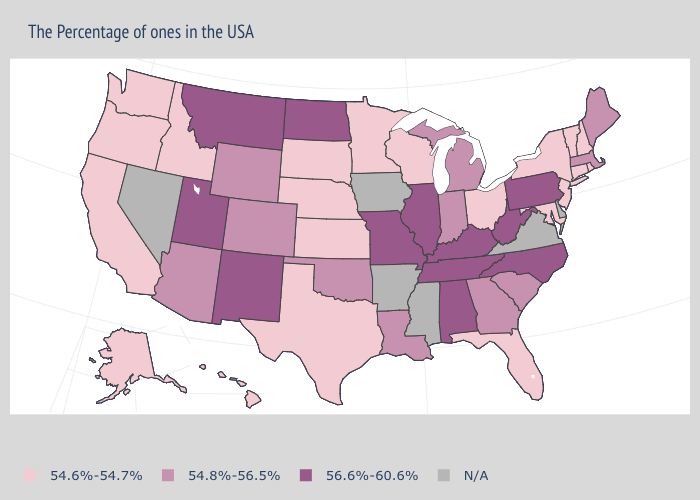Name the states that have a value in the range N/A?
Write a very short answer. Delaware, Virginia, Mississippi, Arkansas, Iowa, Nevada. Does the first symbol in the legend represent the smallest category?
Write a very short answer. Yes. Among the states that border Florida , does Alabama have the highest value?
Be succinct. Yes. What is the value of Idaho?
Concise answer only. 54.6%-54.7%. What is the value of Wisconsin?
Answer briefly. 54.6%-54.7%. Does Kansas have the highest value in the MidWest?
Concise answer only. No. What is the highest value in the USA?
Quick response, please. 56.6%-60.6%. What is the value of Kansas?
Short answer required. 54.6%-54.7%. Name the states that have a value in the range N/A?
Keep it brief. Delaware, Virginia, Mississippi, Arkansas, Iowa, Nevada. Does Maryland have the lowest value in the South?
Concise answer only. Yes. What is the lowest value in the Northeast?
Quick response, please. 54.6%-54.7%. What is the lowest value in the West?
Answer briefly. 54.6%-54.7%. How many symbols are there in the legend?
Write a very short answer. 4. 